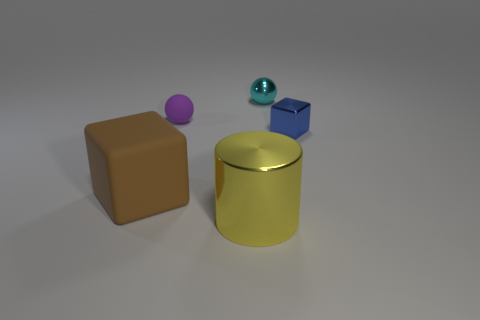Add 2 tiny metallic objects. How many objects exist? 7 Subtract all balls. How many objects are left? 3 Add 1 large yellow things. How many large yellow things are left? 2 Add 3 rubber things. How many rubber things exist? 5 Subtract 0 green spheres. How many objects are left? 5 Subtract all large purple things. Subtract all big metal objects. How many objects are left? 4 